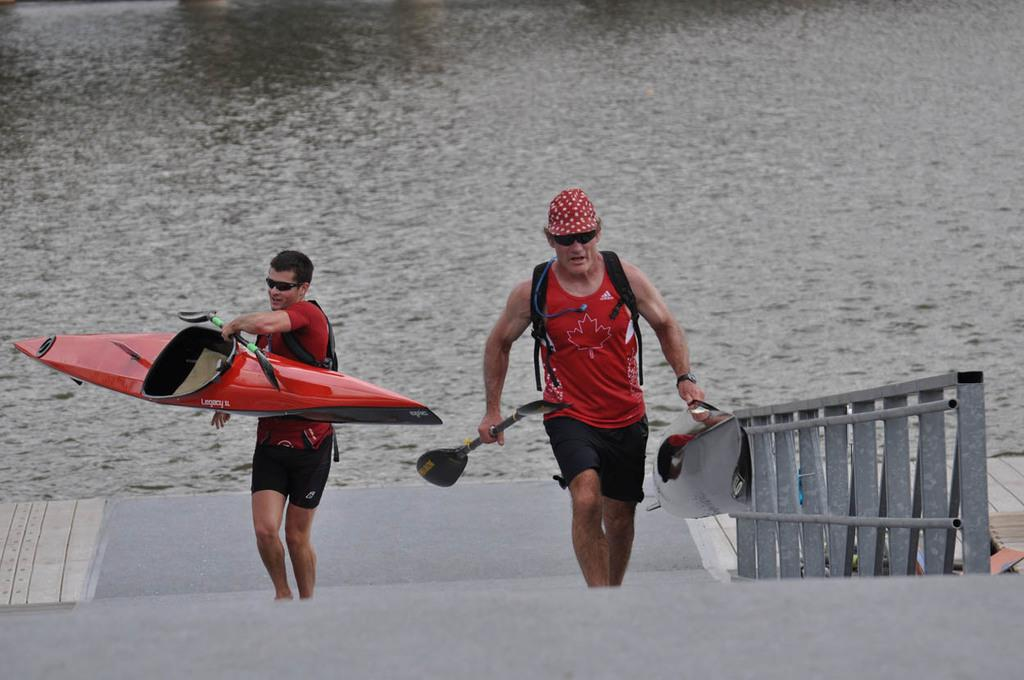Who or what can be seen in the image? There are people in the image. What are the people doing in the image? The people are walking on stairs and holding a boat. What is visible in the background of the image? There is water visible at the back side of the image. What type of toothbrush is being used by the people in the image? There is no toothbrush present in the image. How many visitors are visible in the image? There is no mention of visitors in the image; it features people walking on stairs and holding a boat. 